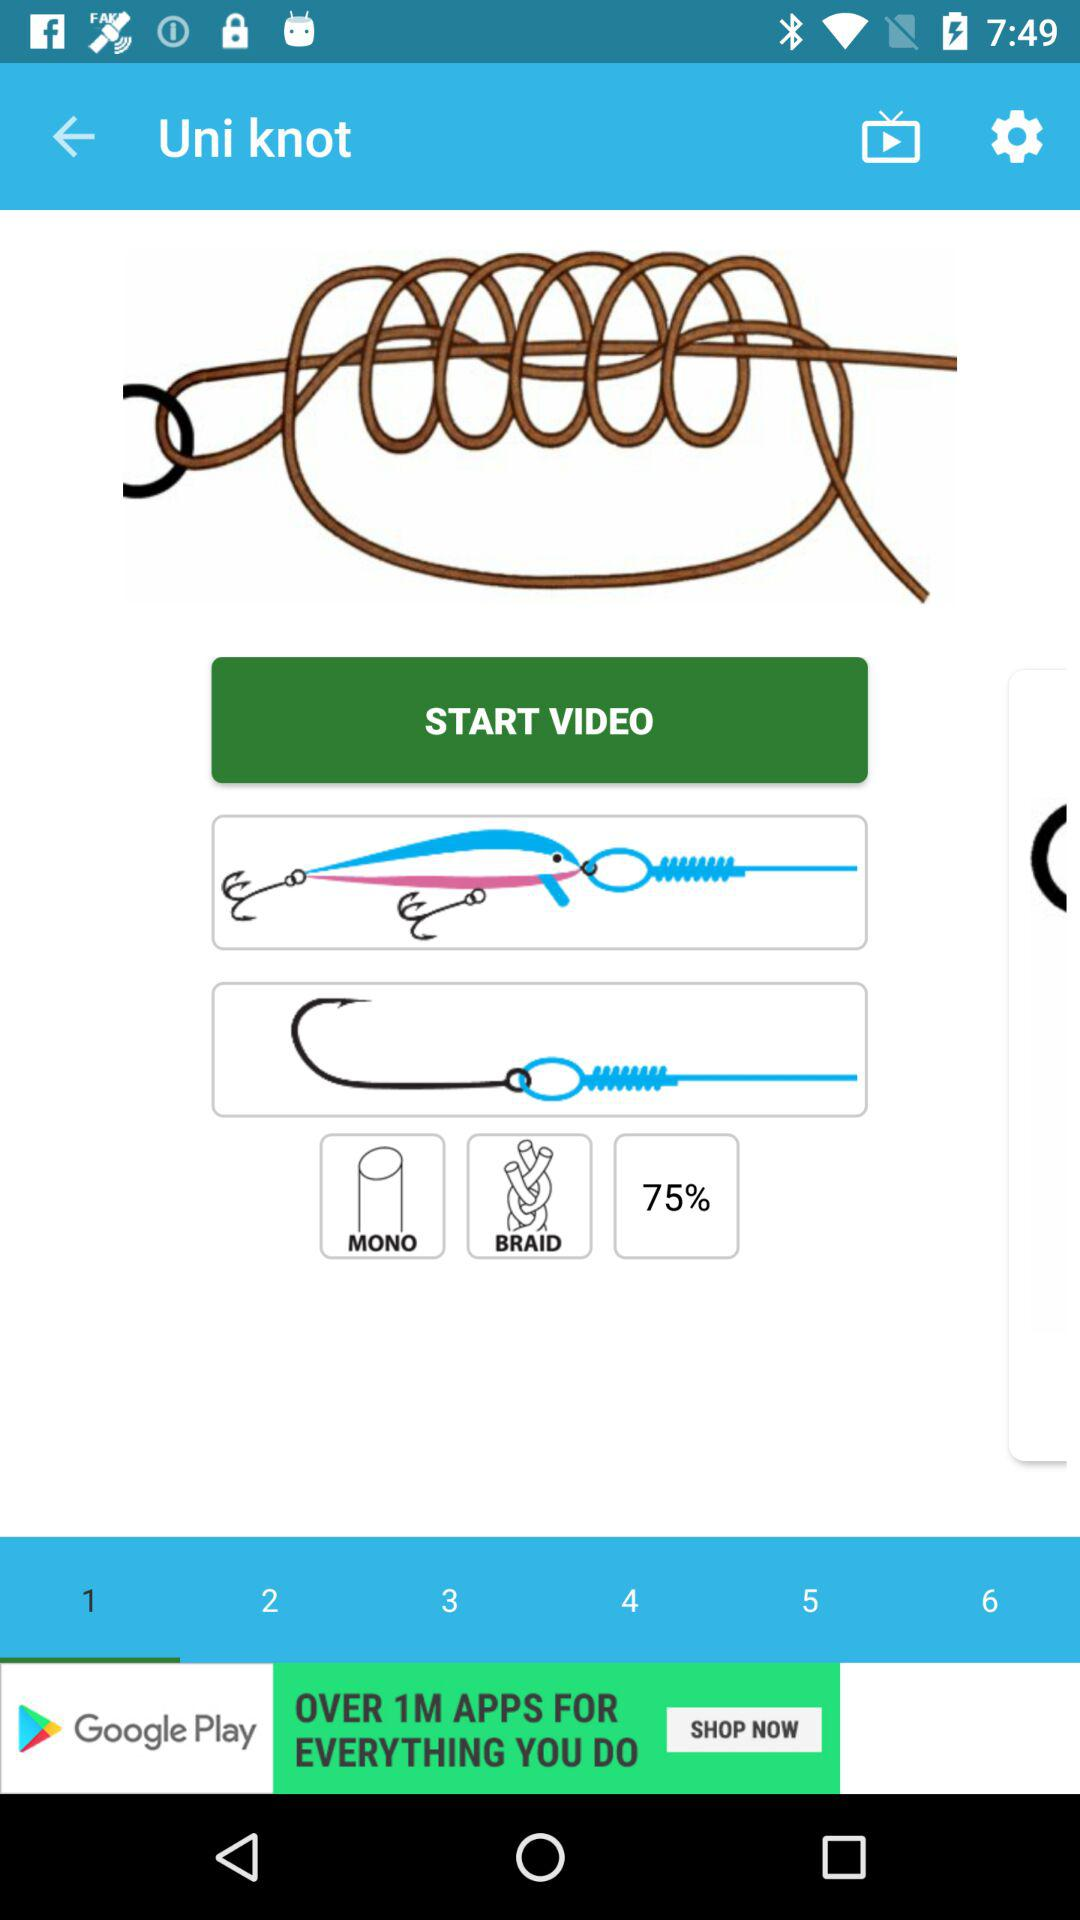Which number is selected? The selected number is "1". 